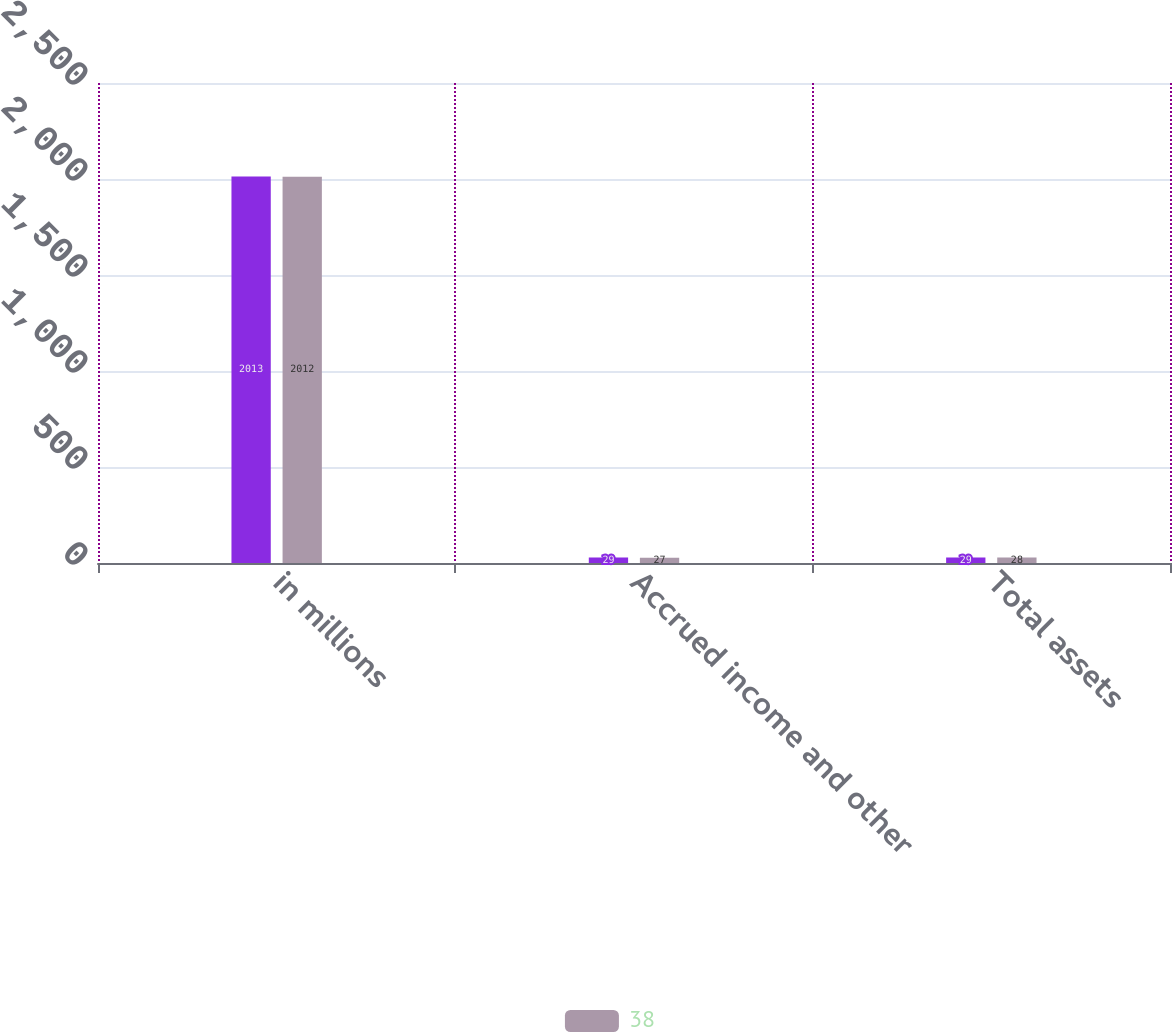Convert chart. <chart><loc_0><loc_0><loc_500><loc_500><stacked_bar_chart><ecel><fcel>in millions<fcel>Accrued income and other<fcel>Total assets<nl><fcel>nan<fcel>2013<fcel>29<fcel>29<nl><fcel>38<fcel>2012<fcel>27<fcel>28<nl></chart> 